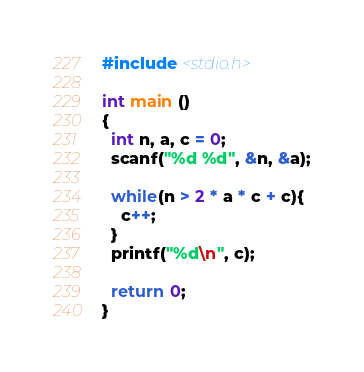Convert code to text. <code><loc_0><loc_0><loc_500><loc_500><_C_>#include <stdio.h>

int main ()
{
  int n, a, c = 0;
  scanf("%d %d", &n, &a);
  
  while(n > 2 * a * c + c){
    c++;
  }
  printf("%d\n", c);
  
  return 0;
}</code> 